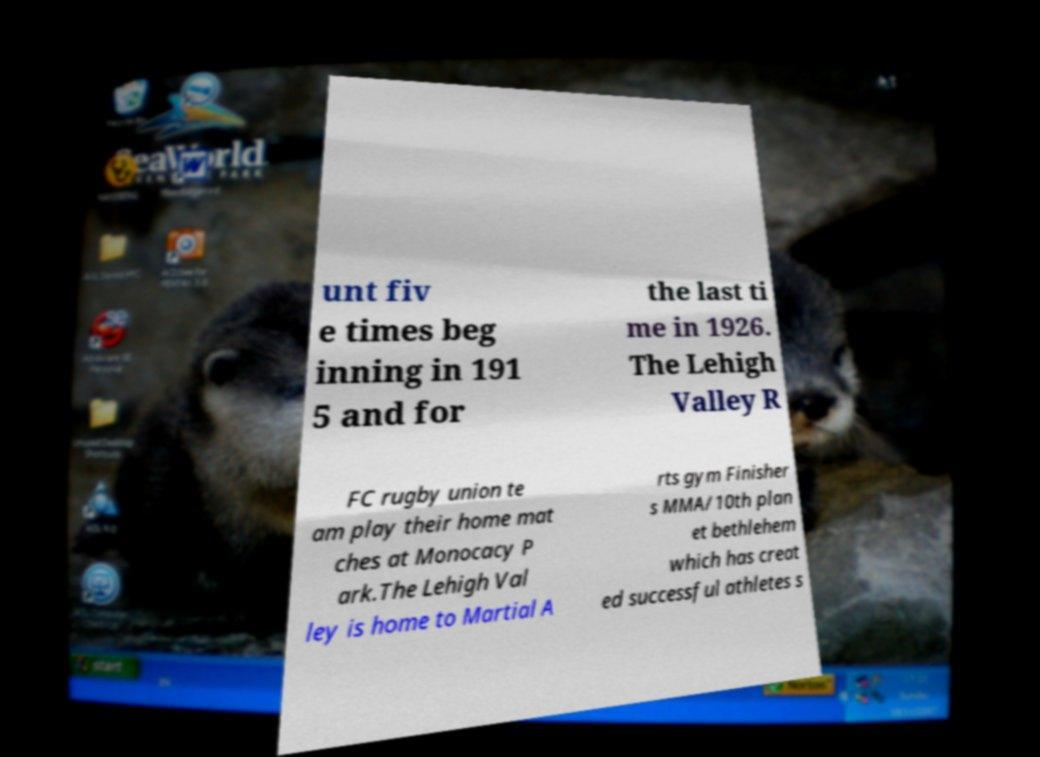There's text embedded in this image that I need extracted. Can you transcribe it verbatim? unt fiv e times beg inning in 191 5 and for the last ti me in 1926. The Lehigh Valley R FC rugby union te am play their home mat ches at Monocacy P ark.The Lehigh Val ley is home to Martial A rts gym Finisher s MMA/10th plan et bethlehem which has creat ed successful athletes s 